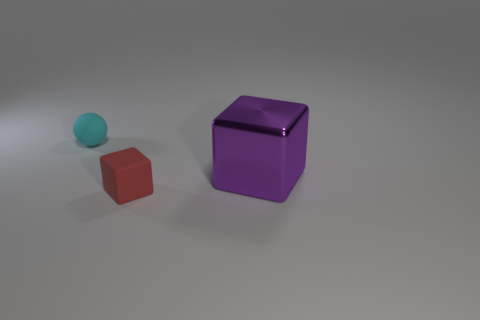Add 3 yellow shiny cubes. How many objects exist? 6 Subtract all balls. How many objects are left? 2 Subtract all big brown things. Subtract all red matte things. How many objects are left? 2 Add 1 small cyan rubber spheres. How many small cyan rubber spheres are left? 2 Add 1 large cubes. How many large cubes exist? 2 Subtract 0 purple balls. How many objects are left? 3 